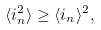<formula> <loc_0><loc_0><loc_500><loc_500>\langle i _ { n } ^ { 2 } \rangle \geq \langle i _ { n } \rangle ^ { 2 } ,</formula> 